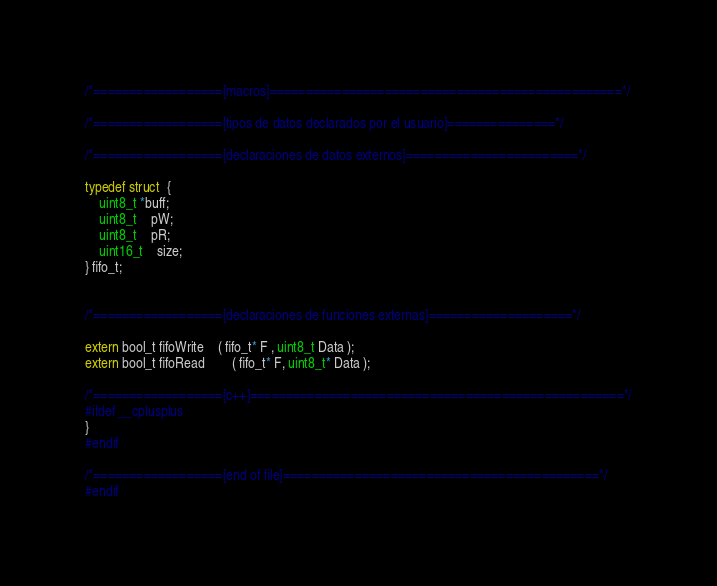Convert code to text. <code><loc_0><loc_0><loc_500><loc_500><_C_>
/*==================[macros]=================================================*/

/*==================[tipos de datos declarados por el usuario]===============*/

/*==================[declaraciones de datos externos]========================*/

typedef struct  {
	uint8_t *buff;
	uint8_t	pW;
	uint8_t	pR;
	uint16_t	size;
} fifo_t;


/*==================[declaraciones de funciones externas]====================*/

extern bool_t fifoWrite 	( fifo_t* F , uint8_t Data );
extern bool_t fifoRead 		( fifo_t* F, uint8_t* Data );

/*==================[c++]====================================================*/
#ifdef __cplusplus
}
#endif

/*==================[end of file]============================================*/
#endif


</code> 